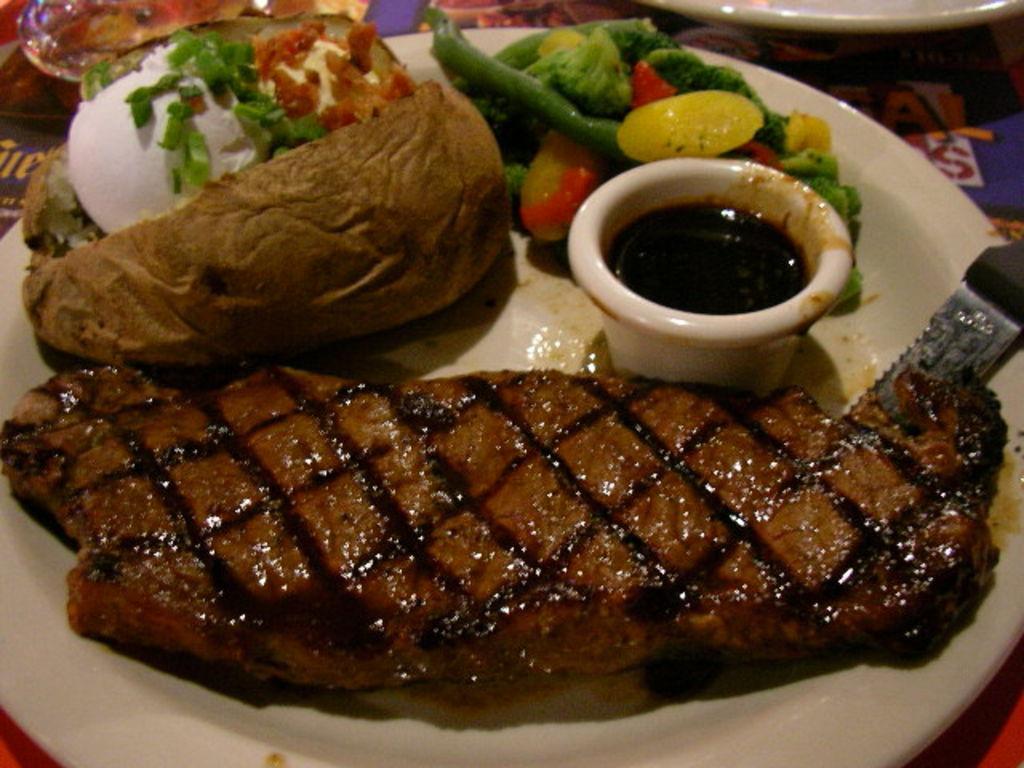In one or two sentences, can you explain what this image depicts? In this picture, we can see a table, on that table, we can see a plate. In the plate, we can see some food items and a cup with some liquid, knife, vegetables. On the right side of the table, we can also see another edge of the plate. 